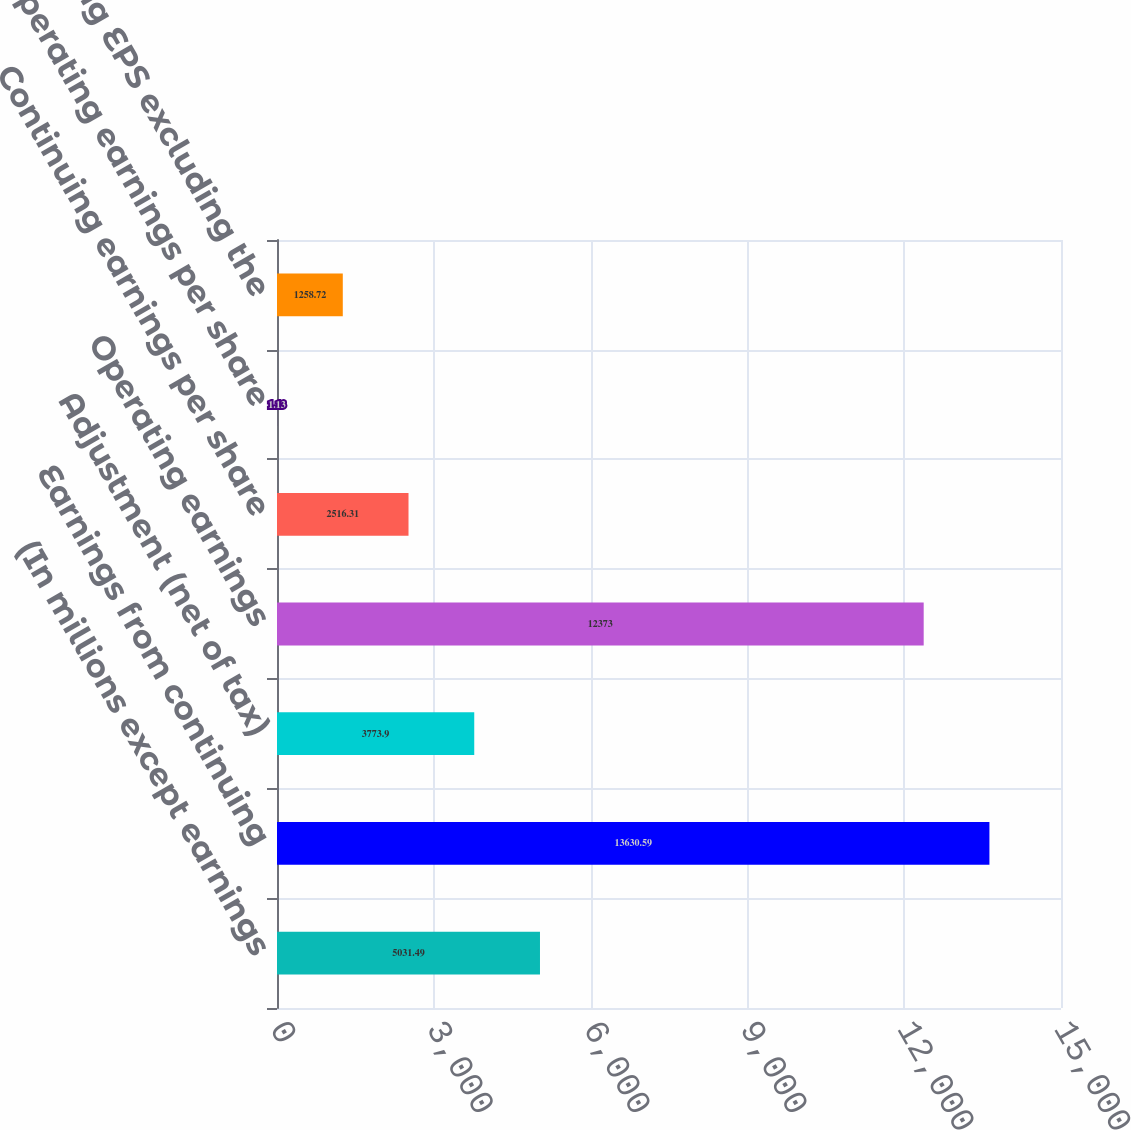Convert chart. <chart><loc_0><loc_0><loc_500><loc_500><bar_chart><fcel>(In millions except earnings<fcel>Earnings from continuing<fcel>Adjustment (net of tax)<fcel>Operating earnings<fcel>Continuing earnings per share<fcel>Operating earnings per share<fcel>Operating EPS excluding the<nl><fcel>5031.49<fcel>13630.6<fcel>3773.9<fcel>12373<fcel>2516.31<fcel>1.13<fcel>1258.72<nl></chart> 